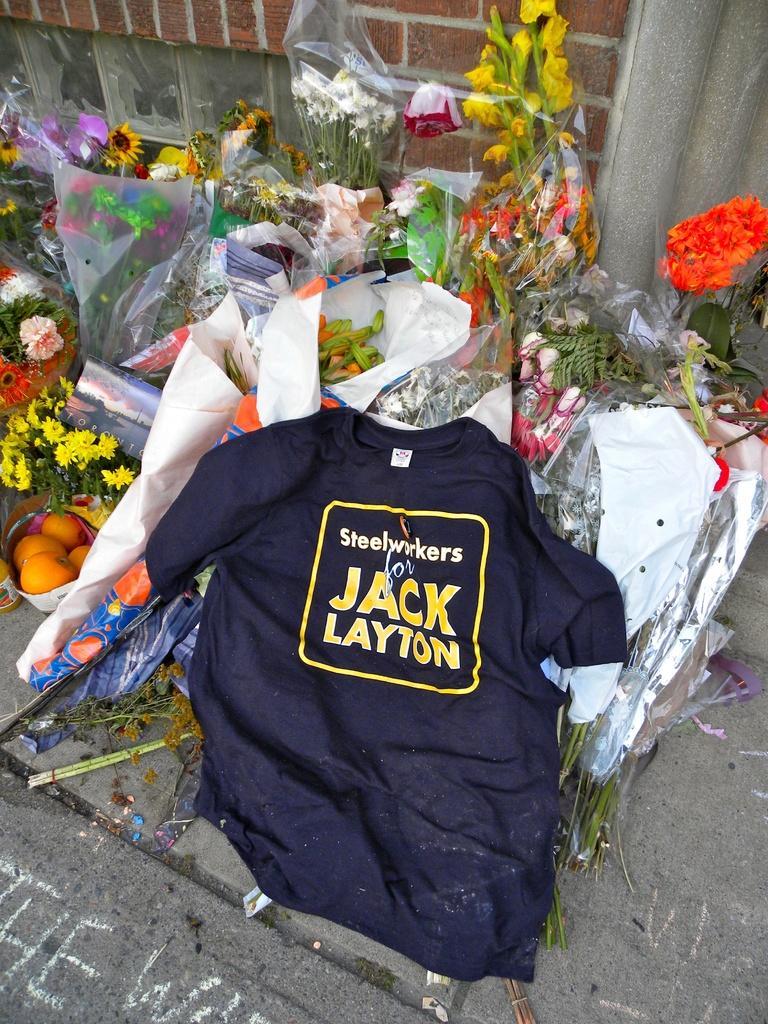How would you summarize this image in a sentence or two? In the image we can see a T-shirt, black in color, on it there is a text. We can even see there are many flower bookies. This is a footpath, brick wall and fruits. 